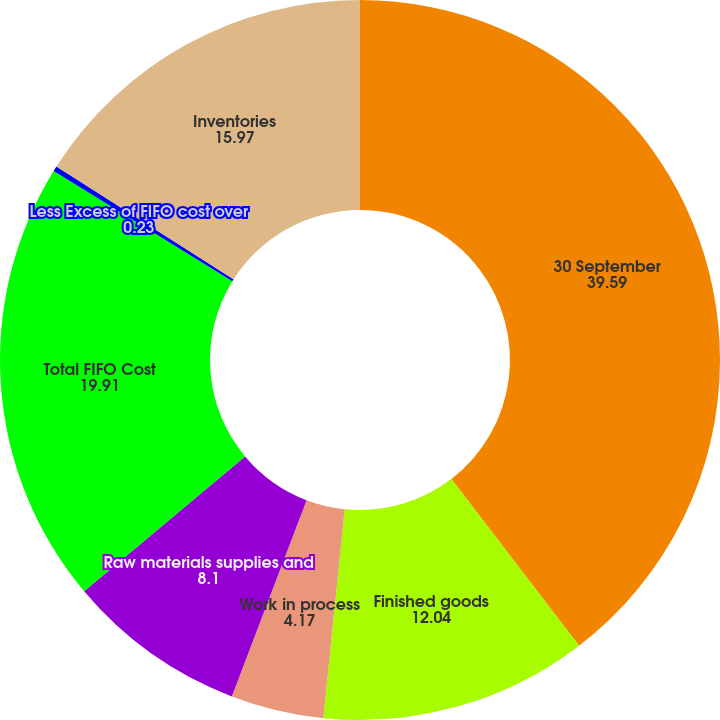<chart> <loc_0><loc_0><loc_500><loc_500><pie_chart><fcel>30 September<fcel>Finished goods<fcel>Work in process<fcel>Raw materials supplies and<fcel>Total FIFO Cost<fcel>Less Excess of FIFO cost over<fcel>Inventories<nl><fcel>39.59%<fcel>12.04%<fcel>4.17%<fcel>8.1%<fcel>19.91%<fcel>0.23%<fcel>15.97%<nl></chart> 